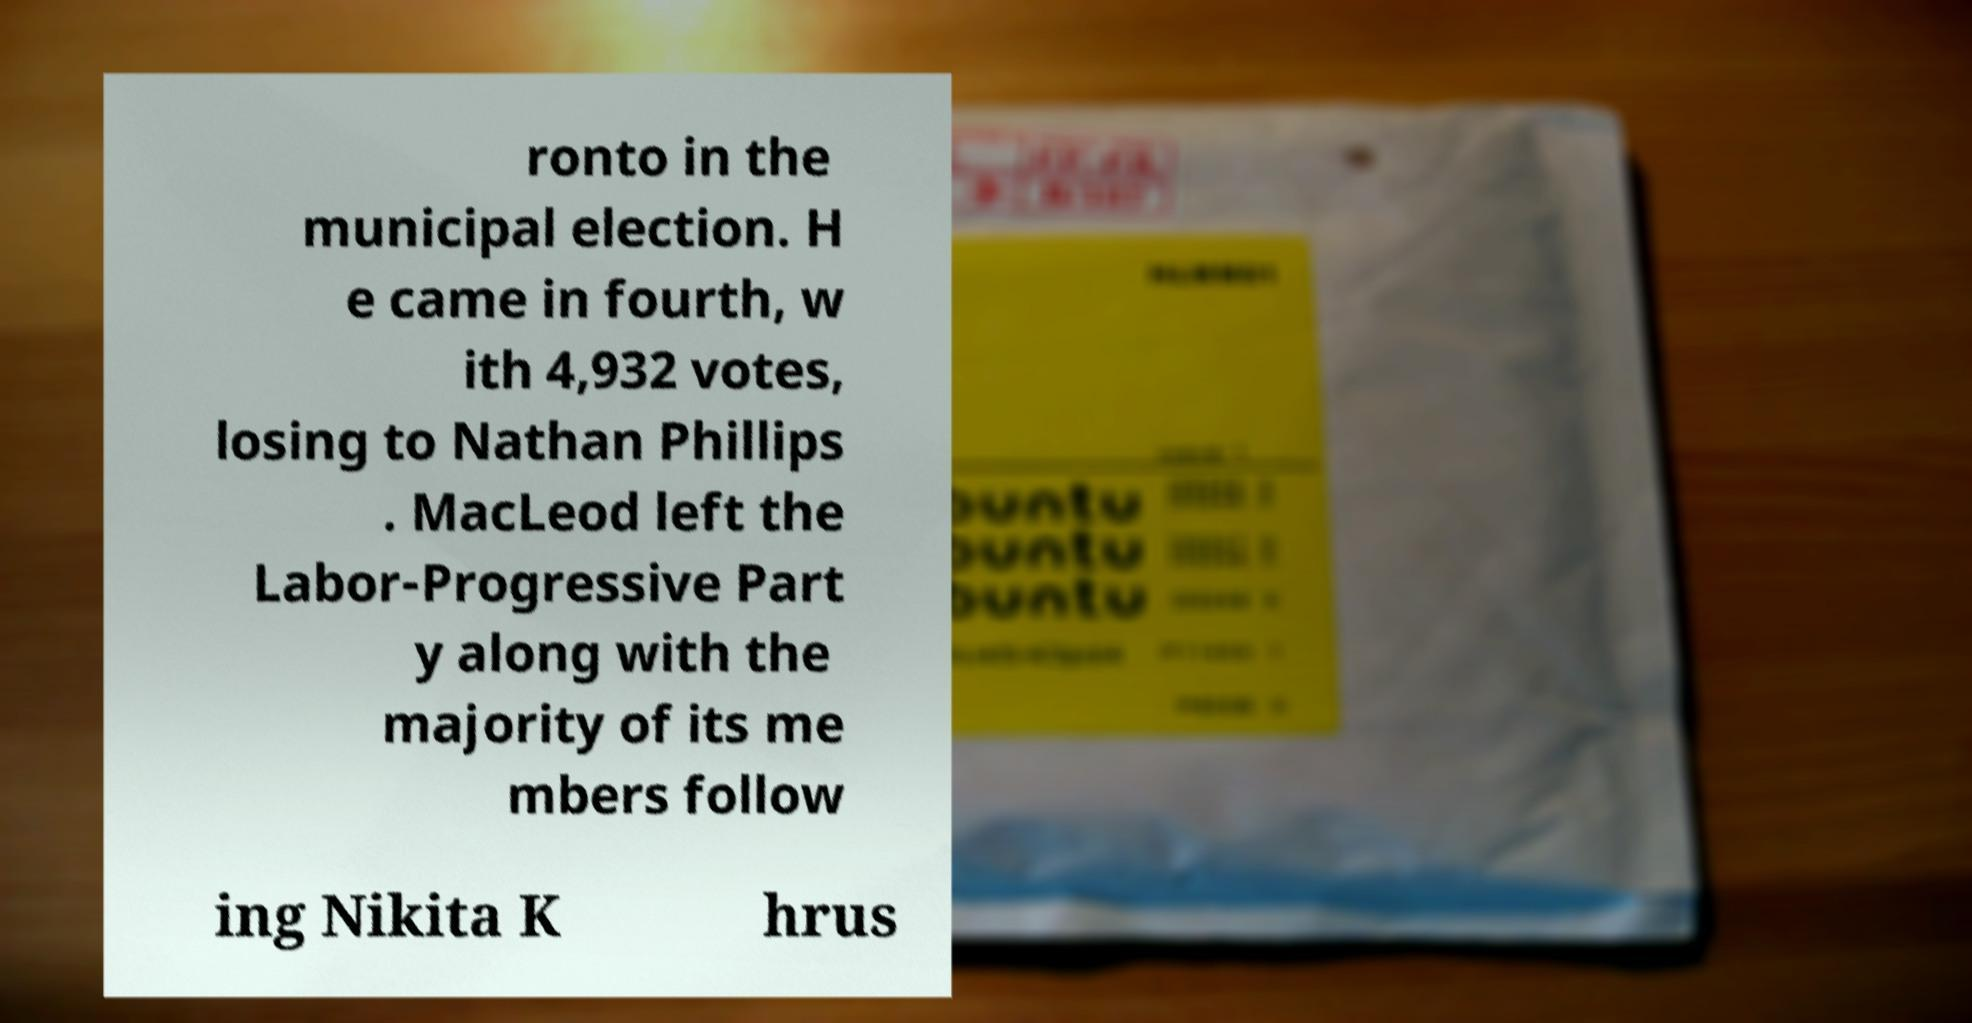Please identify and transcribe the text found in this image. ronto in the municipal election. H e came in fourth, w ith 4,932 votes, losing to Nathan Phillips . MacLeod left the Labor-Progressive Part y along with the majority of its me mbers follow ing Nikita K hrus 